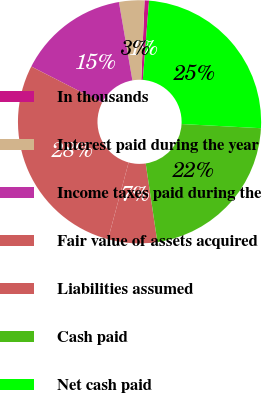<chart> <loc_0><loc_0><loc_500><loc_500><pie_chart><fcel>In thousands<fcel>Interest paid during the year<fcel>Income taxes paid during the<fcel>Fair value of assets acquired<fcel>Liabilities assumed<fcel>Cash paid<fcel>Net cash paid<nl><fcel>0.59%<fcel>3.37%<fcel>14.77%<fcel>28.34%<fcel>6.52%<fcel>21.82%<fcel>24.59%<nl></chart> 